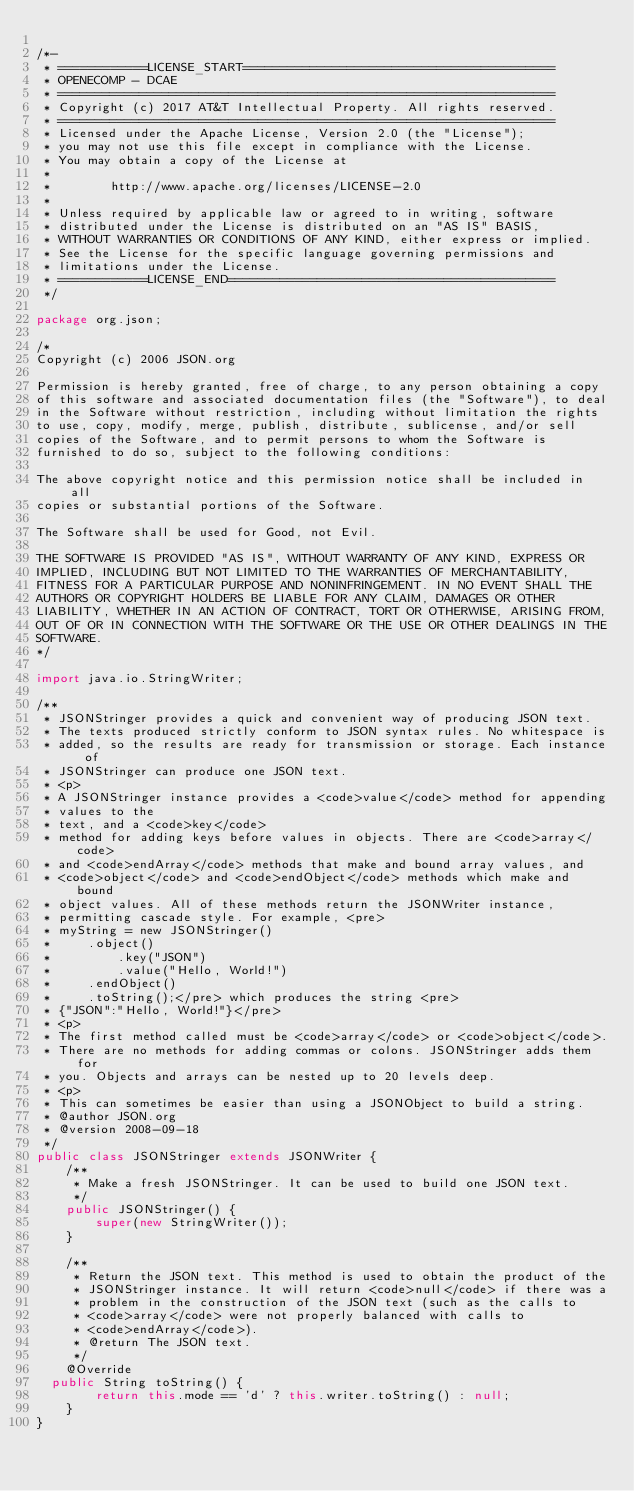<code> <loc_0><loc_0><loc_500><loc_500><_Java_>
/*-
 * ============LICENSE_START==========================================
 * OPENECOMP - DCAE
 * ===================================================================
 * Copyright (c) 2017 AT&T Intellectual Property. All rights reserved.
 * ===================================================================
 * Licensed under the Apache License, Version 2.0 (the "License");
 * you may not use this file except in compliance with the License.
 * You may obtain a copy of the License at
 *
 *        http://www.apache.org/licenses/LICENSE-2.0 
 *
 * Unless required by applicable law or agreed to in writing, software
 * distributed under the License is distributed on an "AS IS" BASIS,
 * WITHOUT WARRANTIES OR CONDITIONS OF ANY KIND, either express or implied.
 * See the License for the specific language governing permissions and
 * limitations under the License.
 * ============LICENSE_END============================================
 */
	
package org.json;

/*
Copyright (c) 2006 JSON.org

Permission is hereby granted, free of charge, to any person obtaining a copy
of this software and associated documentation files (the "Software"), to deal
in the Software without restriction, including without limitation the rights
to use, copy, modify, merge, publish, distribute, sublicense, and/or sell
copies of the Software, and to permit persons to whom the Software is
furnished to do so, subject to the following conditions:

The above copyright notice and this permission notice shall be included in all
copies or substantial portions of the Software.

The Software shall be used for Good, not Evil.

THE SOFTWARE IS PROVIDED "AS IS", WITHOUT WARRANTY OF ANY KIND, EXPRESS OR
IMPLIED, INCLUDING BUT NOT LIMITED TO THE WARRANTIES OF MERCHANTABILITY,
FITNESS FOR A PARTICULAR PURPOSE AND NONINFRINGEMENT. IN NO EVENT SHALL THE
AUTHORS OR COPYRIGHT HOLDERS BE LIABLE FOR ANY CLAIM, DAMAGES OR OTHER
LIABILITY, WHETHER IN AN ACTION OF CONTRACT, TORT OR OTHERWISE, ARISING FROM,
OUT OF OR IN CONNECTION WITH THE SOFTWARE OR THE USE OR OTHER DEALINGS IN THE
SOFTWARE.
*/

import java.io.StringWriter;

/**
 * JSONStringer provides a quick and convenient way of producing JSON text.
 * The texts produced strictly conform to JSON syntax rules. No whitespace is
 * added, so the results are ready for transmission or storage. Each instance of
 * JSONStringer can produce one JSON text.
 * <p>
 * A JSONStringer instance provides a <code>value</code> method for appending
 * values to the
 * text, and a <code>key</code>
 * method for adding keys before values in objects. There are <code>array</code>
 * and <code>endArray</code> methods that make and bound array values, and
 * <code>object</code> and <code>endObject</code> methods which make and bound
 * object values. All of these methods return the JSONWriter instance,
 * permitting cascade style. For example, <pre>
 * myString = new JSONStringer()
 *     .object()
 *         .key("JSON")
 *         .value("Hello, World!")
 *     .endObject()
 *     .toString();</pre> which produces the string <pre>
 * {"JSON":"Hello, World!"}</pre>
 * <p>
 * The first method called must be <code>array</code> or <code>object</code>.
 * There are no methods for adding commas or colons. JSONStringer adds them for
 * you. Objects and arrays can be nested up to 20 levels deep.
 * <p>
 * This can sometimes be easier than using a JSONObject to build a string.
 * @author JSON.org
 * @version 2008-09-18
 */
public class JSONStringer extends JSONWriter {
    /**
     * Make a fresh JSONStringer. It can be used to build one JSON text.
     */
    public JSONStringer() {
        super(new StringWriter());
    }

    /**
     * Return the JSON text. This method is used to obtain the product of the
     * JSONStringer instance. It will return <code>null</code> if there was a
     * problem in the construction of the JSON text (such as the calls to
     * <code>array</code> were not properly balanced with calls to
     * <code>endArray</code>).
     * @return The JSON text.
     */
    @Override
	public String toString() {
        return this.mode == 'd' ? this.writer.toString() : null;
    }
}
</code> 